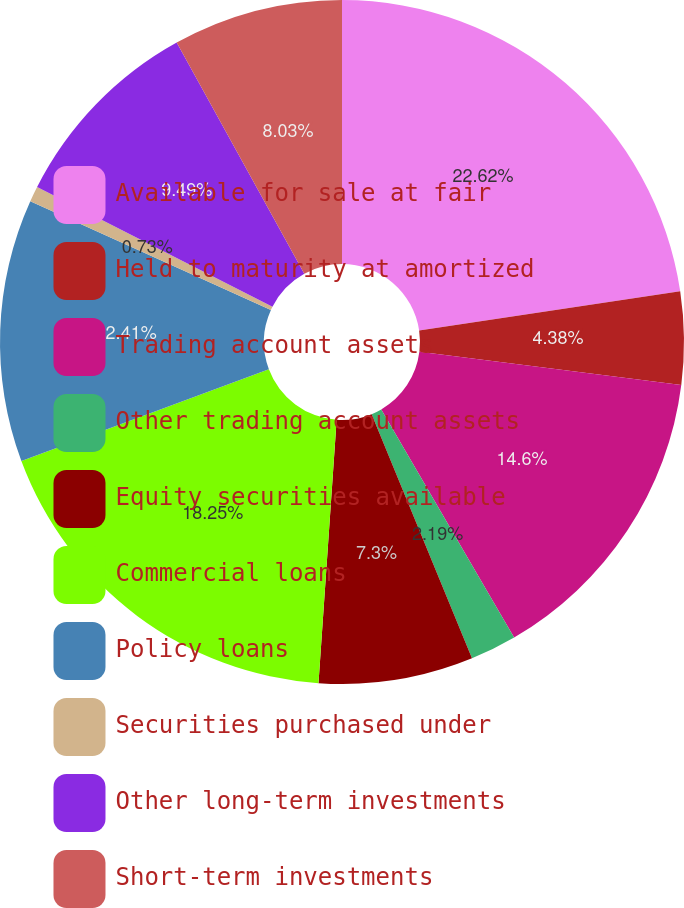<chart> <loc_0><loc_0><loc_500><loc_500><pie_chart><fcel>Available for sale at fair<fcel>Held to maturity at amortized<fcel>Trading account assets<fcel>Other trading account assets<fcel>Equity securities available<fcel>Commercial loans<fcel>Policy loans<fcel>Securities purchased under<fcel>Other long-term investments<fcel>Short-term investments<nl><fcel>22.63%<fcel>4.38%<fcel>14.6%<fcel>2.19%<fcel>7.3%<fcel>18.25%<fcel>12.41%<fcel>0.73%<fcel>9.49%<fcel>8.03%<nl></chart> 